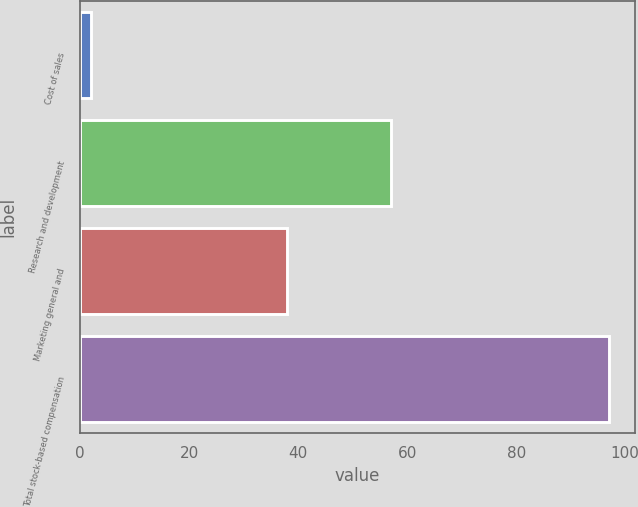<chart> <loc_0><loc_0><loc_500><loc_500><bar_chart><fcel>Cost of sales<fcel>Research and development<fcel>Marketing general and<fcel>Total stock-based compensation<nl><fcel>2<fcel>57<fcel>38<fcel>97<nl></chart> 